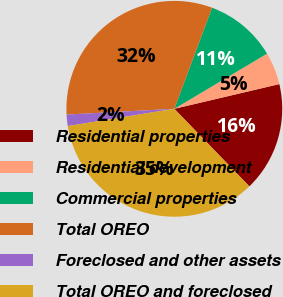Convert chart. <chart><loc_0><loc_0><loc_500><loc_500><pie_chart><fcel>Residential properties<fcel>Residential development<fcel>Commercial properties<fcel>Total OREO<fcel>Foreclosed and other assets<fcel>Total OREO and foreclosed<nl><fcel>16.44%<fcel>4.86%<fcel>10.78%<fcel>31.53%<fcel>1.71%<fcel>34.68%<nl></chart> 